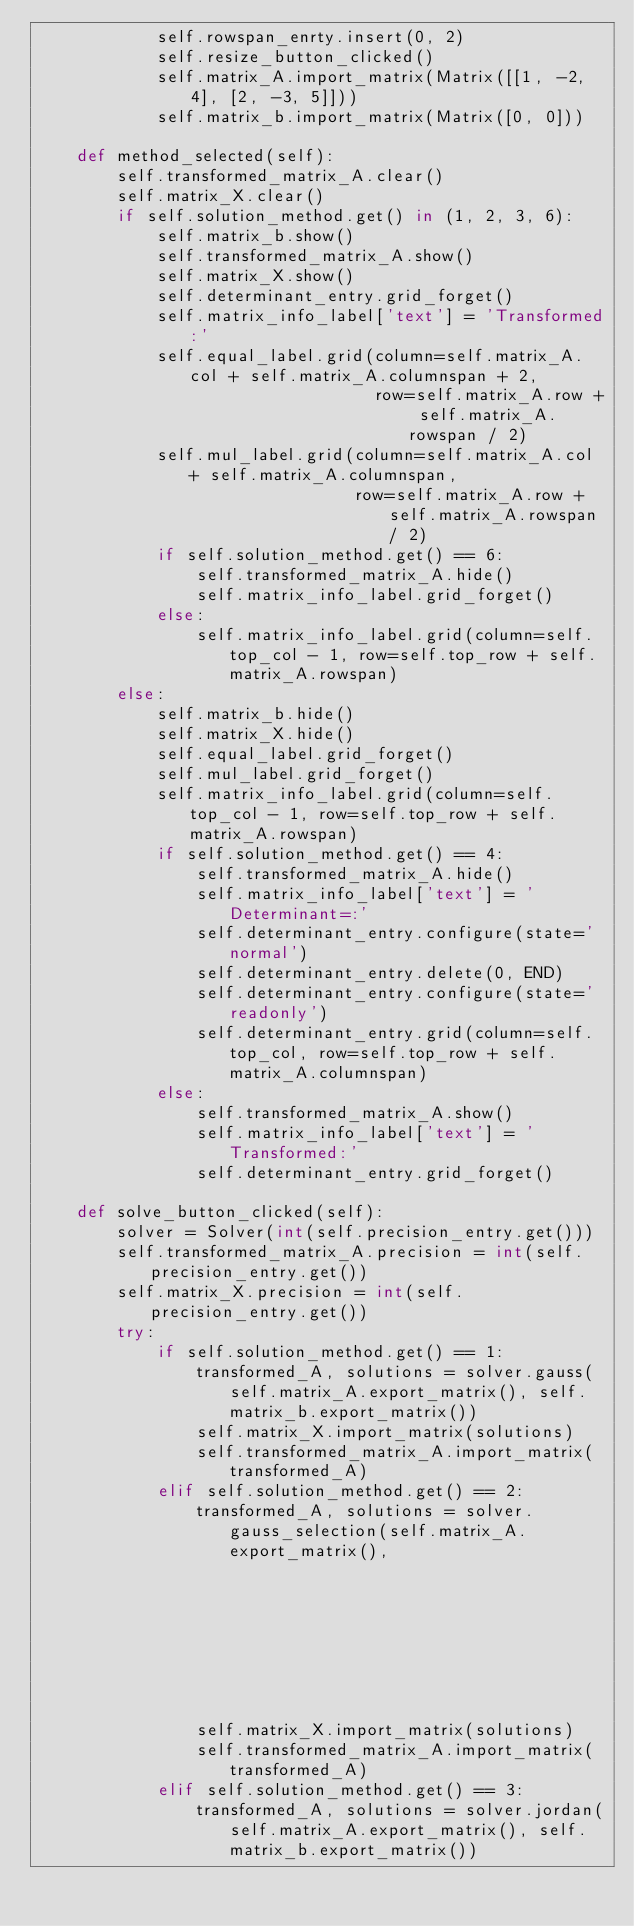Convert code to text. <code><loc_0><loc_0><loc_500><loc_500><_Python_>            self.rowspan_enrty.insert(0, 2)
            self.resize_button_clicked()
            self.matrix_A.import_matrix(Matrix([[1, -2, 4], [2, -3, 5]]))
            self.matrix_b.import_matrix(Matrix([0, 0]))

    def method_selected(self):
        self.transformed_matrix_A.clear()
        self.matrix_X.clear()
        if self.solution_method.get() in (1, 2, 3, 6):
            self.matrix_b.show()
            self.transformed_matrix_A.show()
            self.matrix_X.show()
            self.determinant_entry.grid_forget()
            self.matrix_info_label['text'] = 'Transformed:'
            self.equal_label.grid(column=self.matrix_A.col + self.matrix_A.columnspan + 2,
                                  row=self.matrix_A.row + self.matrix_A.rowspan / 2)
            self.mul_label.grid(column=self.matrix_A.col + self.matrix_A.columnspan,
                                row=self.matrix_A.row + self.matrix_A.rowspan / 2)
            if self.solution_method.get() == 6:
                self.transformed_matrix_A.hide()
                self.matrix_info_label.grid_forget()
            else:
                self.matrix_info_label.grid(column=self.top_col - 1, row=self.top_row + self.matrix_A.rowspan)
        else:
            self.matrix_b.hide()
            self.matrix_X.hide()
            self.equal_label.grid_forget()
            self.mul_label.grid_forget()
            self.matrix_info_label.grid(column=self.top_col - 1, row=self.top_row + self.matrix_A.rowspan)
            if self.solution_method.get() == 4:
                self.transformed_matrix_A.hide()
                self.matrix_info_label['text'] = 'Determinant=:'
                self.determinant_entry.configure(state='normal')
                self.determinant_entry.delete(0, END)
                self.determinant_entry.configure(state='readonly')
                self.determinant_entry.grid(column=self.top_col, row=self.top_row + self.matrix_A.columnspan)
            else:
                self.transformed_matrix_A.show()
                self.matrix_info_label['text'] = 'Transformed:'
                self.determinant_entry.grid_forget()

    def solve_button_clicked(self):
        solver = Solver(int(self.precision_entry.get()))
        self.transformed_matrix_A.precision = int(self.precision_entry.get())
        self.matrix_X.precision = int(self.precision_entry.get())
        try:
            if self.solution_method.get() == 1:
                transformed_A, solutions = solver.gauss(self.matrix_A.export_matrix(), self.matrix_b.export_matrix())
                self.matrix_X.import_matrix(solutions)
                self.transformed_matrix_A.import_matrix(transformed_A)
            elif self.solution_method.get() == 2:
                transformed_A, solutions = solver.gauss_selection(self.matrix_A.export_matrix(),
                                                                  self.matrix_b.export_matrix())
                self.matrix_X.import_matrix(solutions)
                self.transformed_matrix_A.import_matrix(transformed_A)
            elif self.solution_method.get() == 3:
                transformed_A, solutions = solver.jordan(self.matrix_A.export_matrix(), self.matrix_b.export_matrix())</code> 